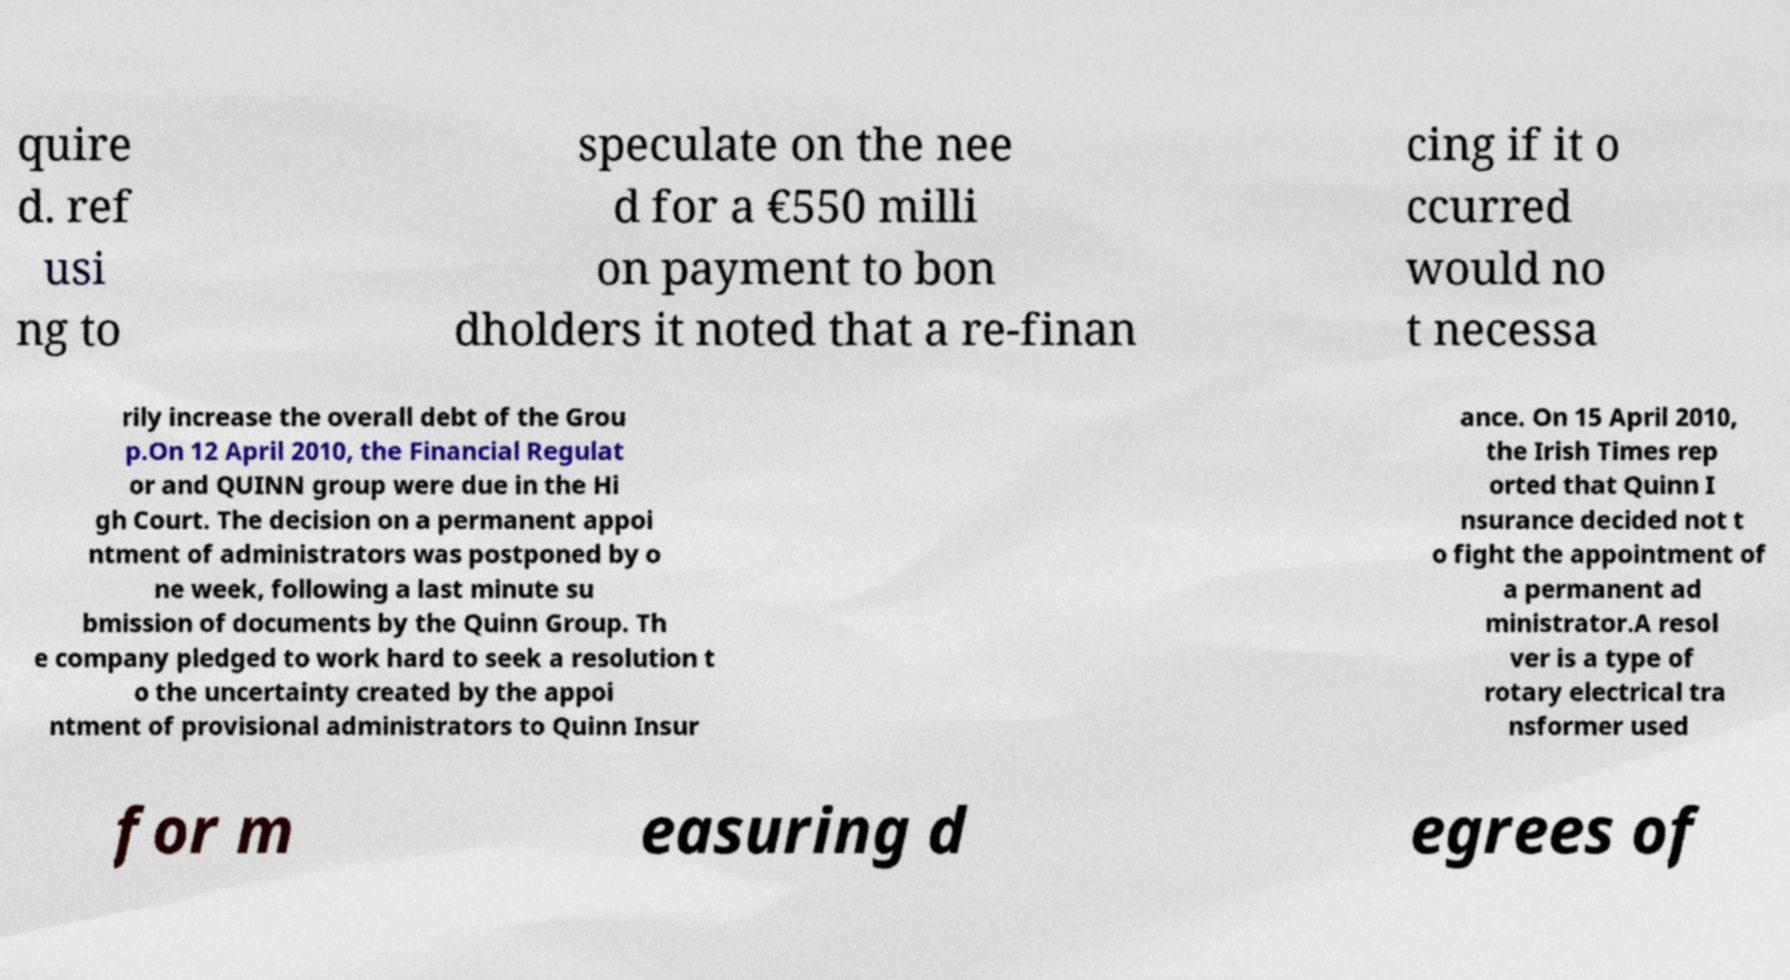Can you read and provide the text displayed in the image?This photo seems to have some interesting text. Can you extract and type it out for me? quire d. ref usi ng to speculate on the nee d for a €550 milli on payment to bon dholders it noted that a re-finan cing if it o ccurred would no t necessa rily increase the overall debt of the Grou p.On 12 April 2010, the Financial Regulat or and QUINN group were due in the Hi gh Court. The decision on a permanent appoi ntment of administrators was postponed by o ne week, following a last minute su bmission of documents by the Quinn Group. Th e company pledged to work hard to seek a resolution t o the uncertainty created by the appoi ntment of provisional administrators to Quinn Insur ance. On 15 April 2010, the Irish Times rep orted that Quinn I nsurance decided not t o fight the appointment of a permanent ad ministrator.A resol ver is a type of rotary electrical tra nsformer used for m easuring d egrees of 